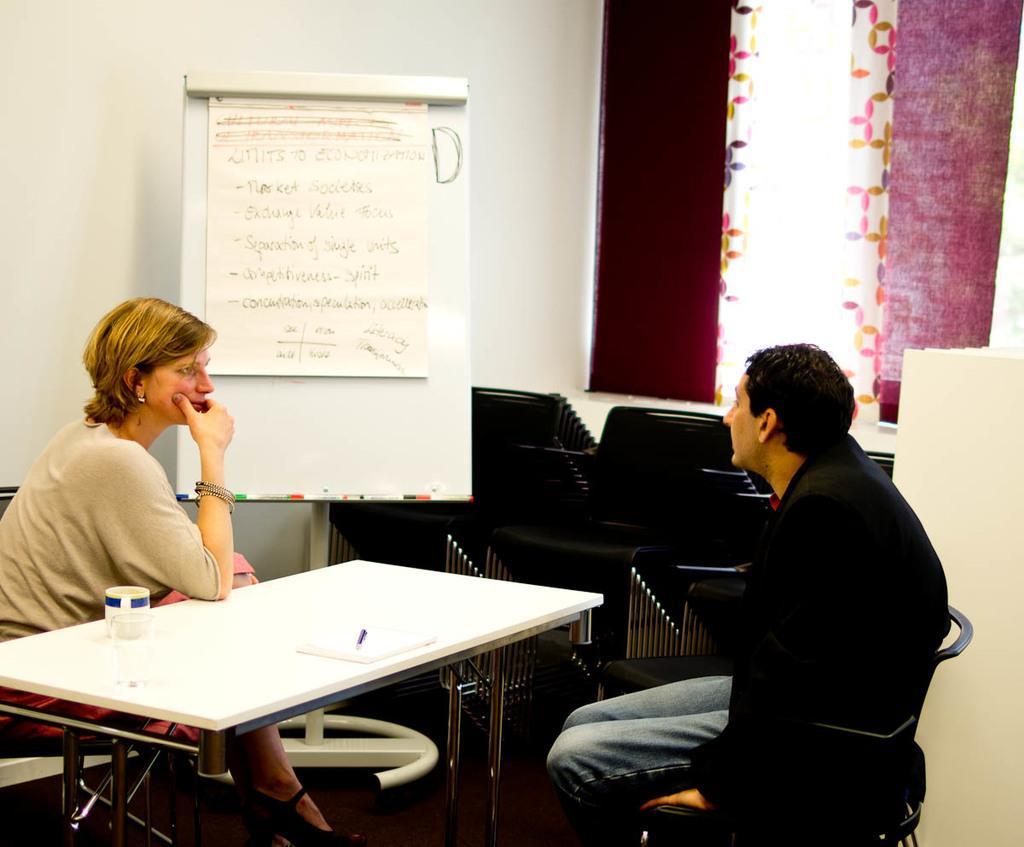How would you summarize this image in a sentence or two? In the image we can see two persons were sitting on the chair around the table. On table we can see some objects. Back we can see board,wall and curtain. 